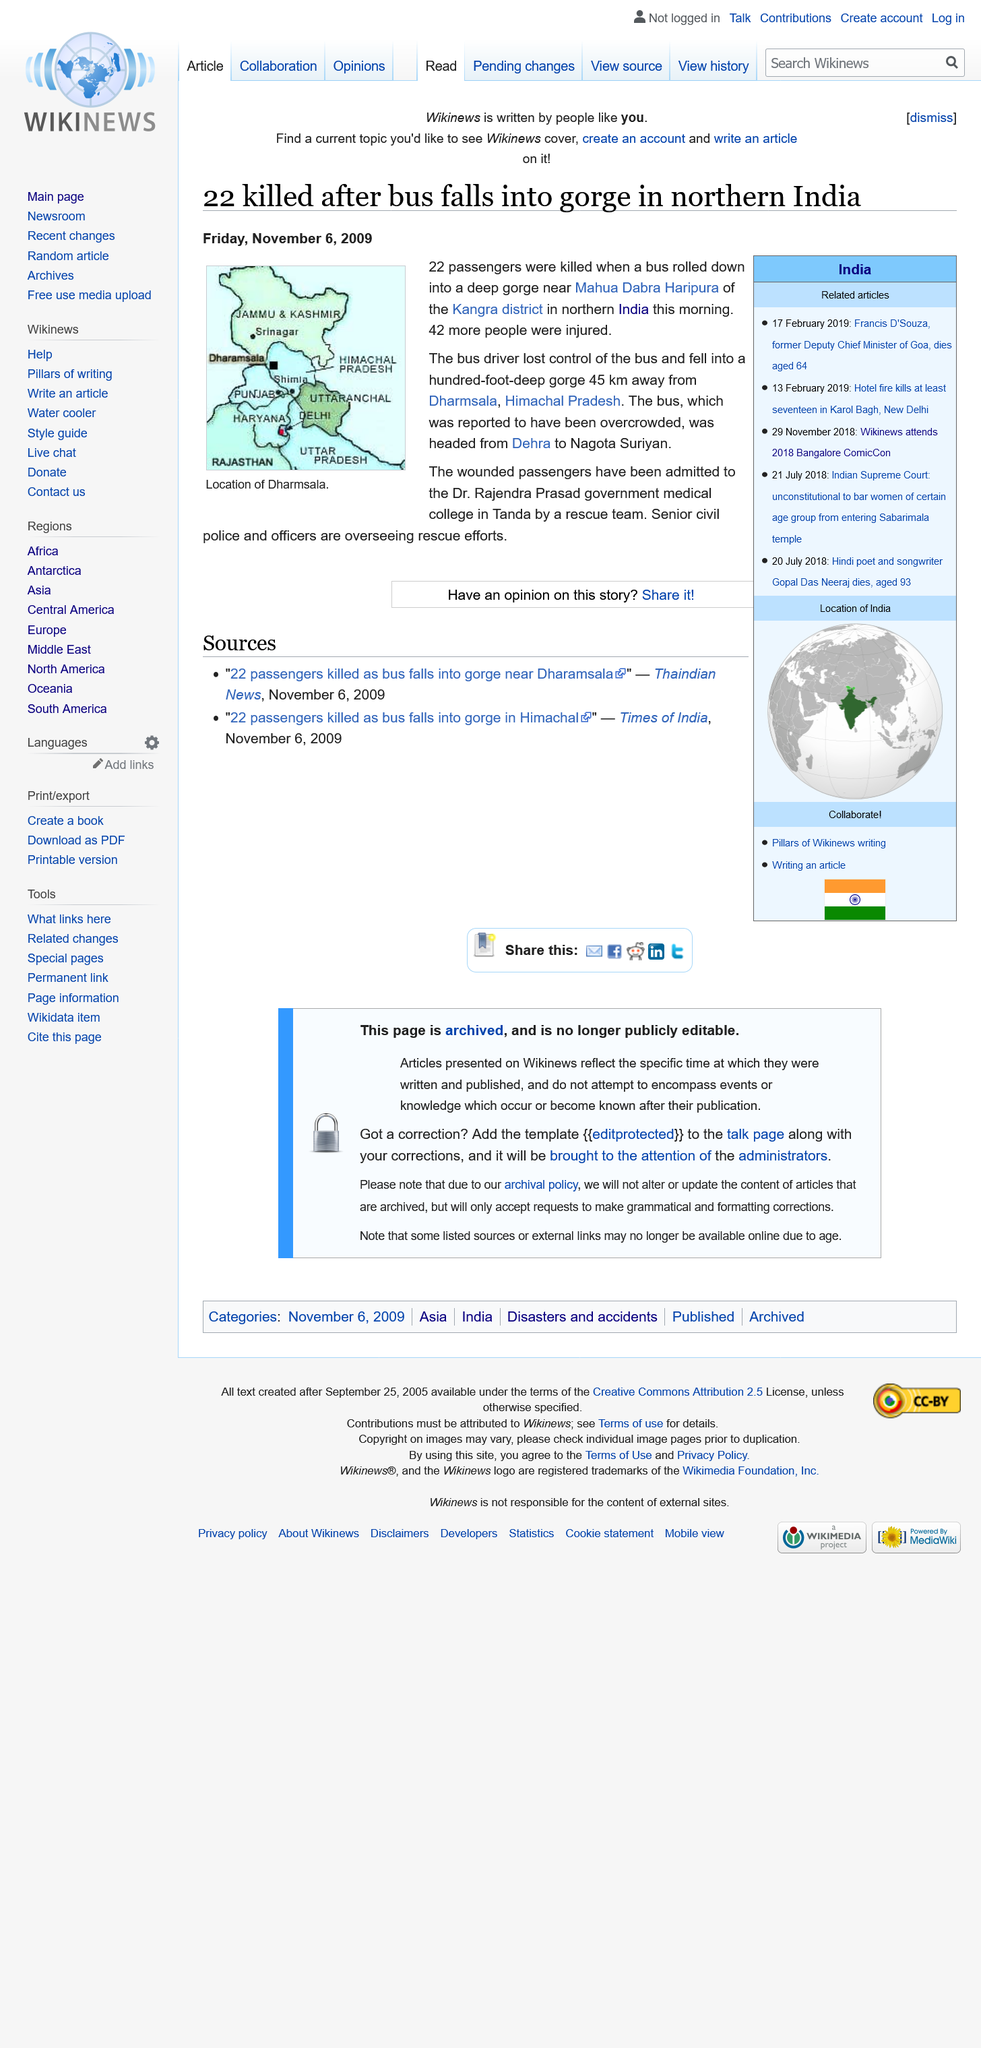Give some essential details in this illustration. The gorge was a hundred feet deep, and the bus fell into it with such force that it caused a huge commotion among the surrounding trees and rocks. The image depicts a map displaying the location of Dharmsala, which is the capital and largest city of the state of Himachal Pradesh in India. A bus plunged into a gorge in India, resulting in the death of 22 passengers. 